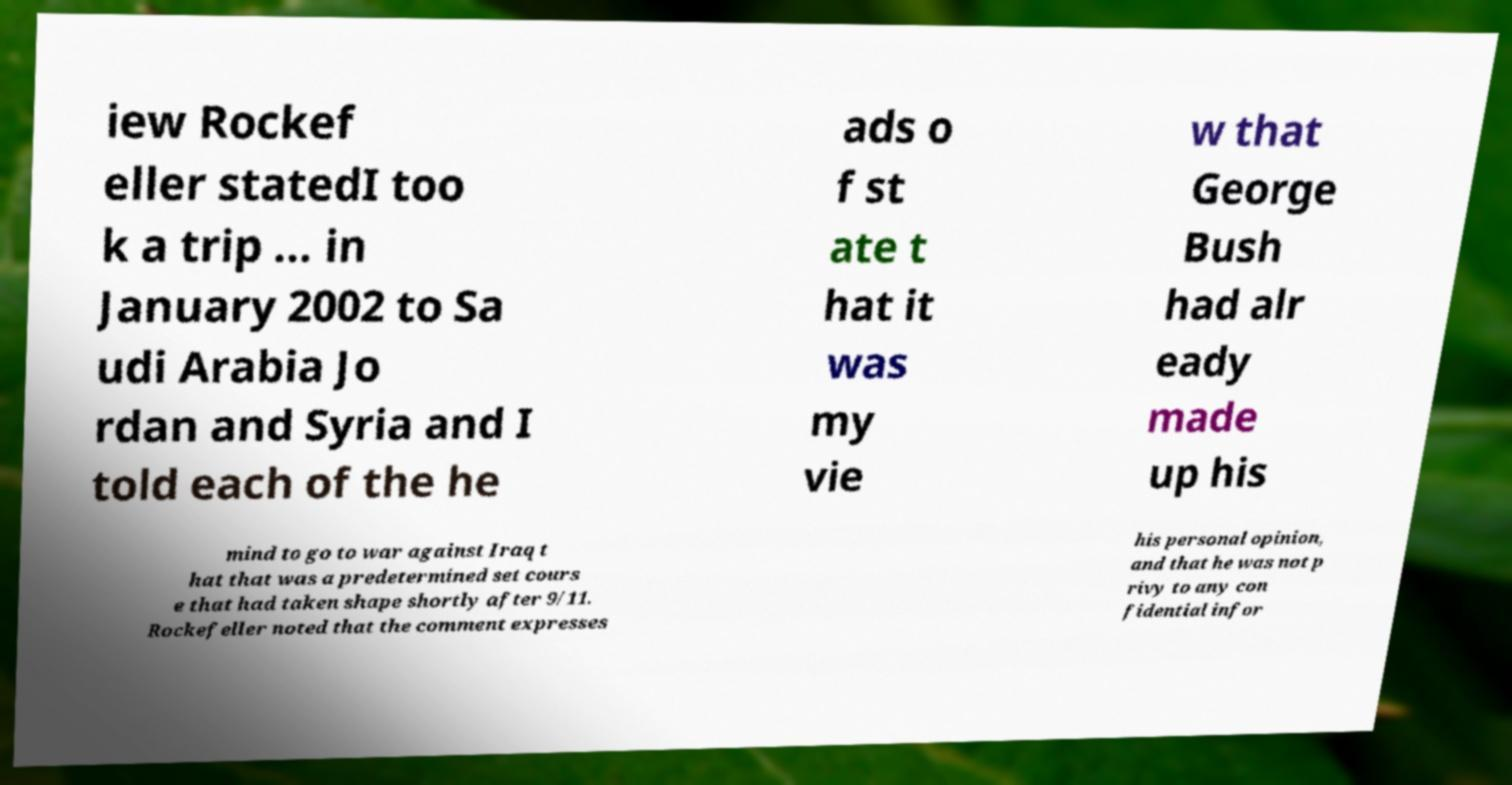I need the written content from this picture converted into text. Can you do that? iew Rockef eller statedI too k a trip ... in January 2002 to Sa udi Arabia Jo rdan and Syria and I told each of the he ads o f st ate t hat it was my vie w that George Bush had alr eady made up his mind to go to war against Iraq t hat that was a predetermined set cours e that had taken shape shortly after 9/11. Rockefeller noted that the comment expresses his personal opinion, and that he was not p rivy to any con fidential infor 